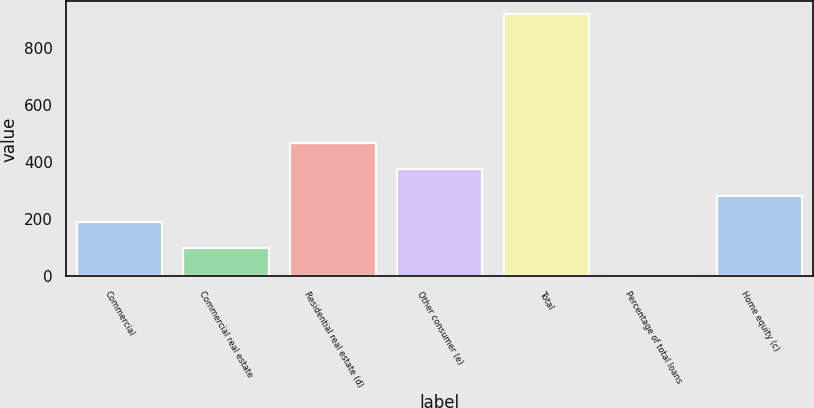Convert chart. <chart><loc_0><loc_0><loc_500><loc_500><bar_chart><fcel>Commercial<fcel>Commercial real estate<fcel>Residential real estate (d)<fcel>Other consumer (e)<fcel>Total<fcel>Percentage of total loans<fcel>Home equity (c)<nl><fcel>191.85<fcel>100<fcel>467.4<fcel>375.55<fcel>919<fcel>0.49<fcel>283.7<nl></chart> 